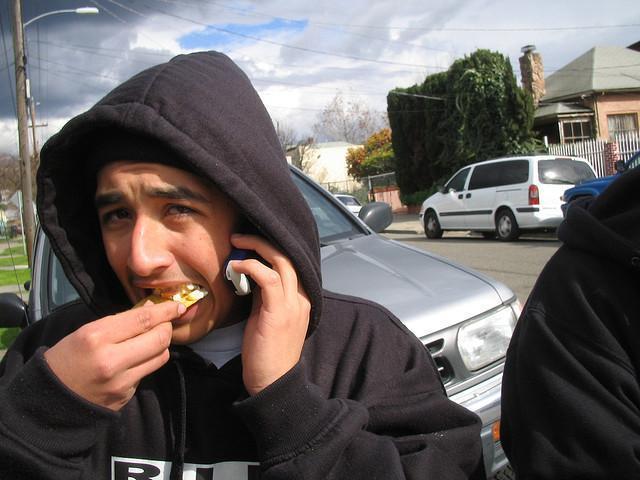How many cars are in the photo?
Give a very brief answer. 2. How many people are there?
Give a very brief answer. 2. How many white cats are there in the image?
Give a very brief answer. 0. 